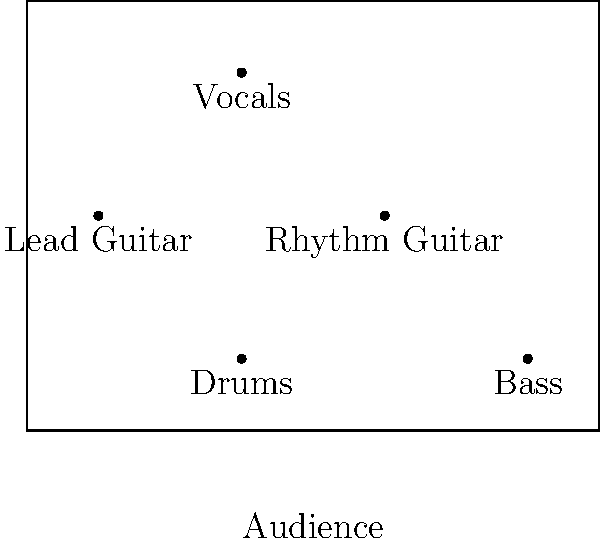In a typical rock band stage setup, which instrument is usually positioned at the front and center of the stage? To answer this question, let's analyze the typical layout of a rock band stage:

1. The diagram shows a top-down view of a standard rock band stage setup.
2. There are five positions marked for different instruments: Drums, Bass, Lead Guitar, Rhythm Guitar, and Vocals.
3. The audience is positioned at the bottom of the diagram, facing the stage.
4. In most rock band setups, the vocalist is the main focus and typically positioned at the front and center of the stage.
5. This allows the vocalist to engage with the audience directly and be easily seen by all audience members.
6. In the diagram, we can see that the "Vocals" position is indeed at the front (closest to the audience) and center of the stage.
7. Other instruments like guitars and bass are usually positioned to the sides, while drums are typically at the back due to their size and setup requirements.

Therefore, based on this typical rock band stage arrangement, the instrument (or rather, the band member) positioned at the front and center of the stage is the vocalist.
Answer: Vocals 